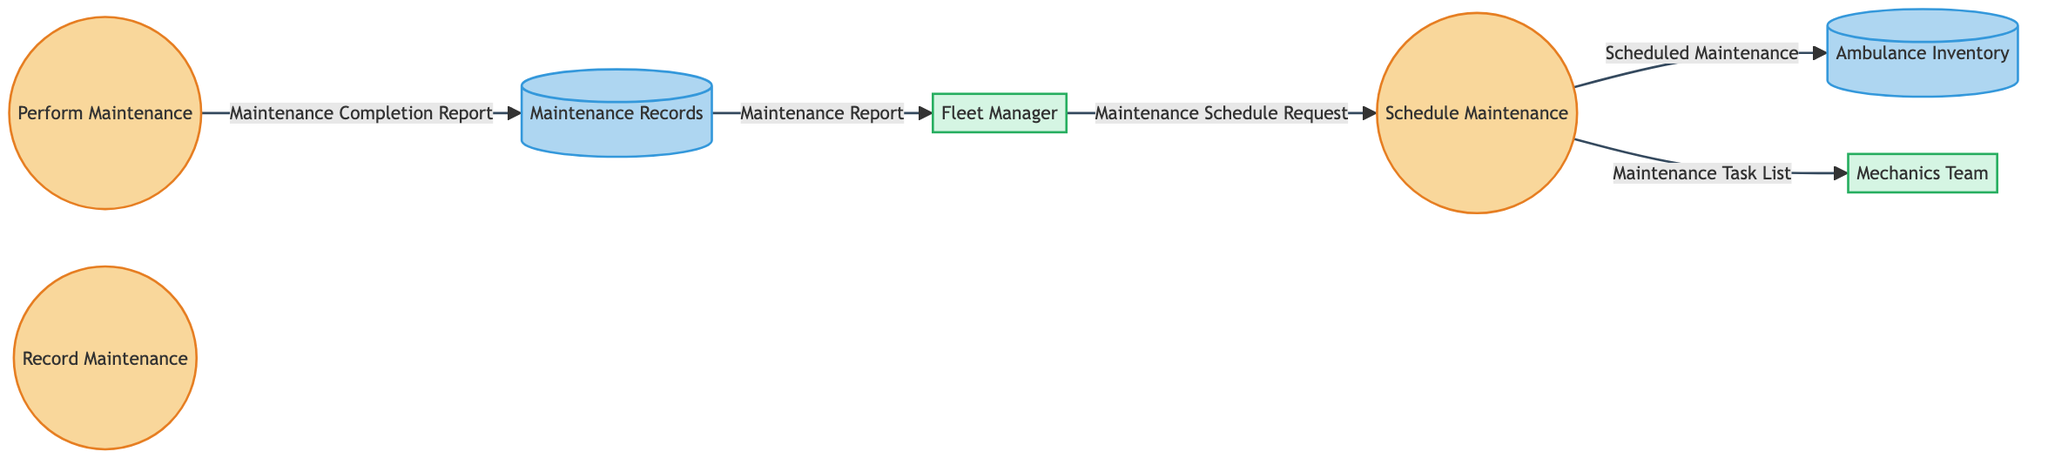What is the name of the first process in the diagram? The first process is identified by the ID "P1" and is labeled as "Schedule Maintenance." It is the topmost process in the flowchart.
Answer: Schedule Maintenance Which external entity is responsible for performing maintenance activities? The external entity tasked with performing maintenance activities is the "Mechanics Team," which is connected to the maintenance process.
Answer: Mechanics Team What type of data does the Fleet Manager send to the Schedule Maintenance process? The Fleet Manager sends a "Maintenance Schedule Request" to the Schedule Maintenance process, initiating the maintenance scheduling activity.
Answer: Maintenance Schedule Request How many processes are depicted in the diagram? There are three distinct processes in the diagram, represented as "Schedule Maintenance," "Perform Maintenance," and "Record Maintenance."
Answer: 3 What is the destination of the data flow labeled "Maintenance Completion Report"? The data flow labeled "Maintenance Completion Report" originates from the "Perform Maintenance" process and flows into the "Maintenance Records" data store, where details of the maintenance performed are logged.
Answer: Maintenance Records What is the relationship between the Scheduled Maintenance process and the Mechanics Team? The Scheduled Maintenance process sends a "Maintenance Task List" to the Mechanics Team, indicating the tasks they need to perform for the scheduled maintenance.
Answer: Maintenance Task List Which data store contains information about the fleet of ambulances? The "Ambulance Inventory" is the repository that contains data regarding the fleet of ambulances utilized by the London Ambulance Service.
Answer: Ambulance Inventory What data does the Maintenance Records store send to the Fleet Manager? The "Maintenance Records" data store provides a "Maintenance Report" to the Fleet Manager, summarizing the maintenance activities that have been completed.
Answer: Maintenance Report What data flow connects the Schedule Maintenance process to the Ambulance Inventory? The data flow from the Schedule Maintenance process to the Ambulance Inventory is labeled as "Scheduled Maintenance," representing the transfer of scheduled maintenance details to the inventory.
Answer: Scheduled Maintenance 